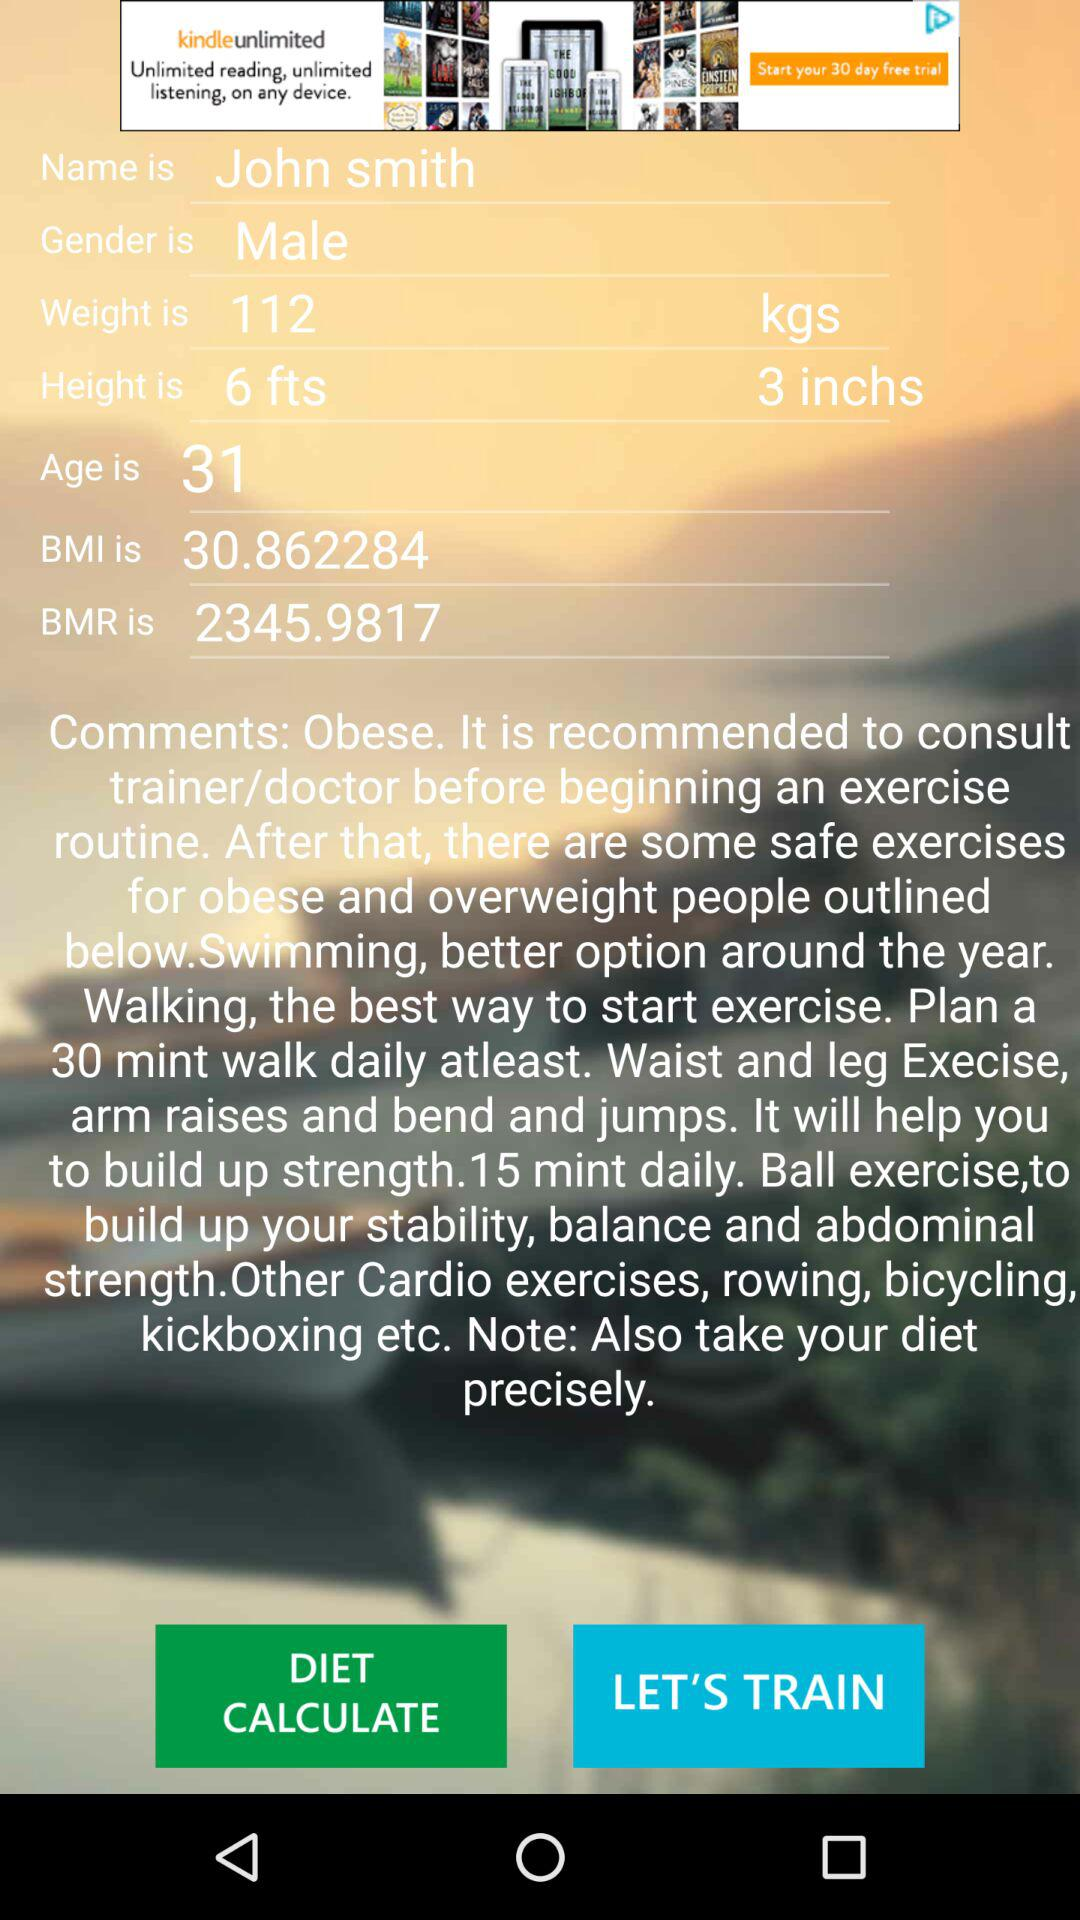What is the user's BMI?
Answer the question using a single word or phrase. 30.862284 